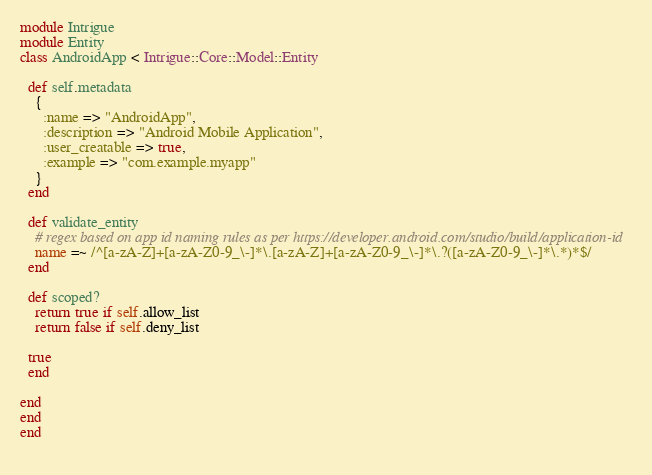<code> <loc_0><loc_0><loc_500><loc_500><_Ruby_>module Intrigue
module Entity
class AndroidApp < Intrigue::Core::Model::Entity

  def self.metadata
    {
      :name => "AndroidApp",
      :description => "Android Mobile Application",
      :user_creatable => true,
      :example => "com.example.myapp"
    }
  end

  def validate_entity
    # regex based on app id naming rules as per https://developer.android.com/studio/build/application-id
    name =~ /^[a-zA-Z]+[a-zA-Z0-9_\-]*\.[a-zA-Z]+[a-zA-Z0-9_\-]*\.?([a-zA-Z0-9_\-]*\.*)*$/
  end

  def scoped?
    return true if self.allow_list
    return false if self.deny_list
  
  true
  end

end
end
end
    </code> 